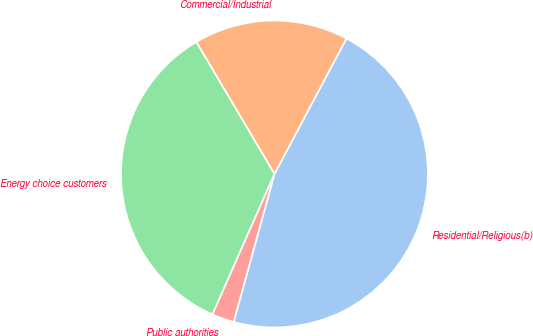Convert chart to OTSL. <chart><loc_0><loc_0><loc_500><loc_500><pie_chart><fcel>Residential/Religious(b)<fcel>Commercial/Industrial<fcel>Energy choice customers<fcel>Public authorities<nl><fcel>46.51%<fcel>16.28%<fcel>34.88%<fcel>2.33%<nl></chart> 